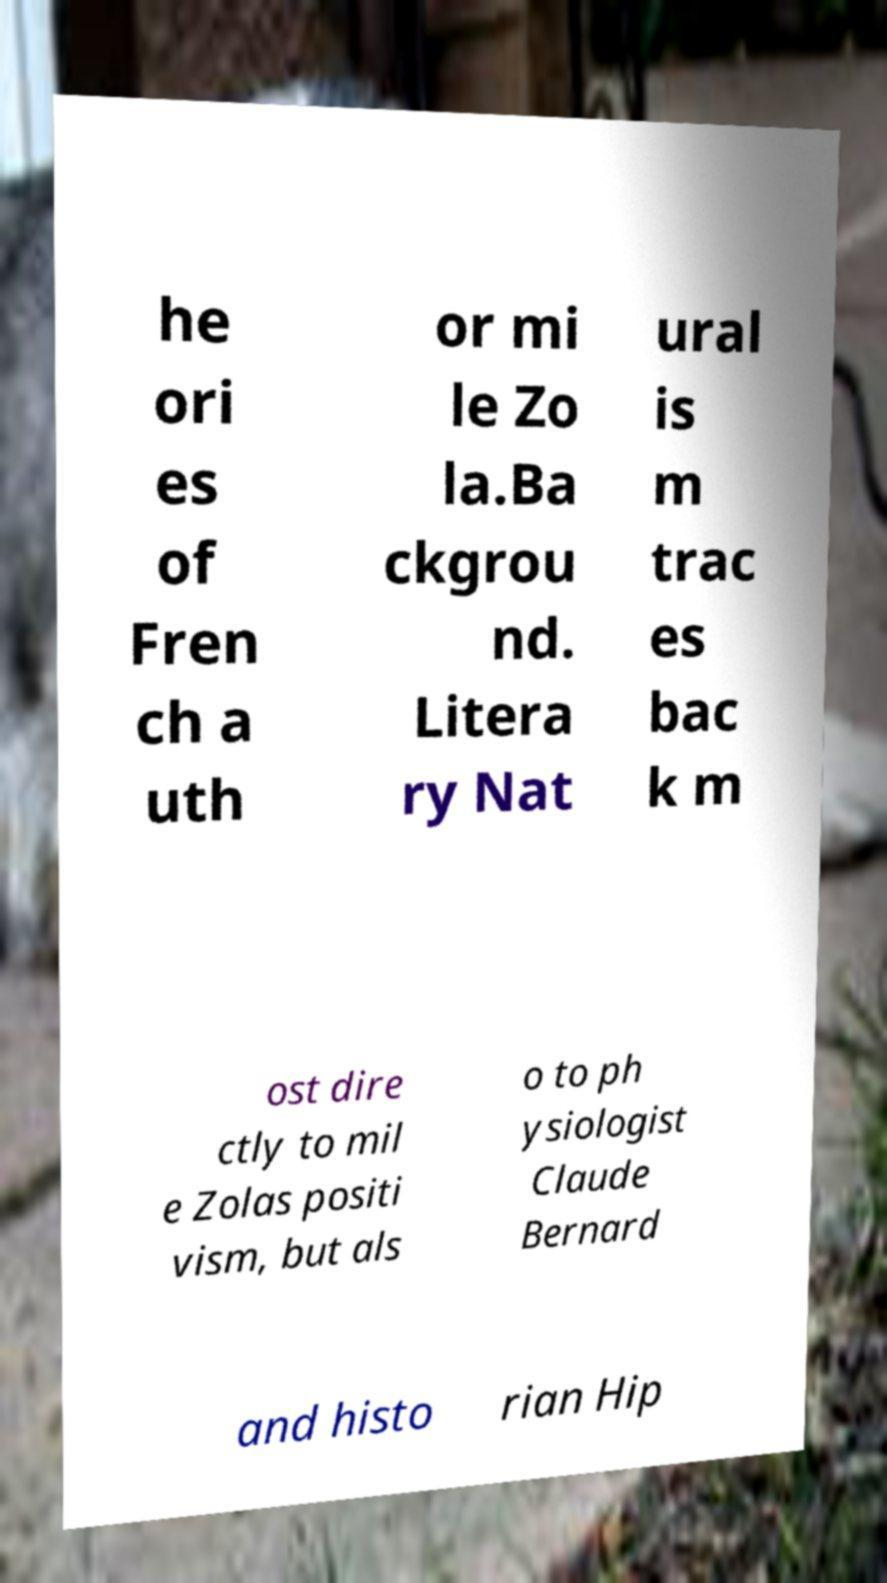Could you extract and type out the text from this image? he ori es of Fren ch a uth or mi le Zo la.Ba ckgrou nd. Litera ry Nat ural is m trac es bac k m ost dire ctly to mil e Zolas positi vism, but als o to ph ysiologist Claude Bernard and histo rian Hip 